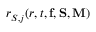<formula> <loc_0><loc_0><loc_500><loc_500>r _ { S , j } ( r , t , { f } , { S } , { M } )</formula> 